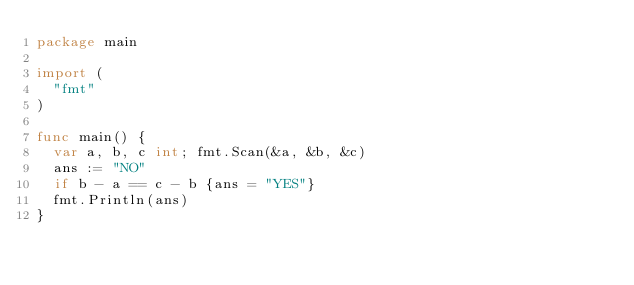<code> <loc_0><loc_0><loc_500><loc_500><_Go_>package main

import (
  "fmt"
)

func main() {
  var a, b, c int; fmt.Scan(&a, &b, &c)
  ans := "NO"
  if b - a == c - b {ans = "YES"}
  fmt.Println(ans)
}</code> 